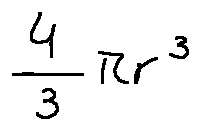<formula> <loc_0><loc_0><loc_500><loc_500>\frac { 4 } { 3 } \pi r ^ { 3 }</formula> 